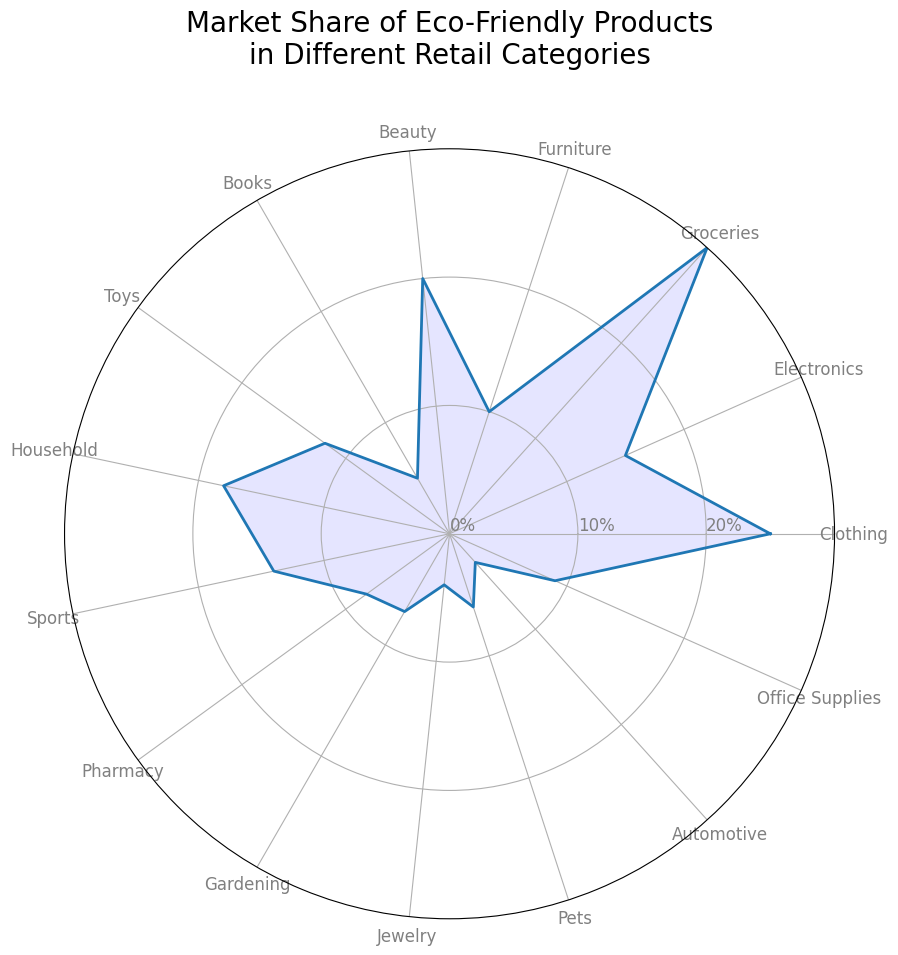Which category has the highest market share of eco-friendly products? Look for the longest segment on the rose chart, which corresponds to the largest percentage. The category with the longest segment is Groceries with 30%.
Answer: Groceries Which category has the lowest market share? Look for the shortest segment on the rose chart, which corresponds to the smallest percentage. The category with the shortest segment is Automotive with 3%.
Answer: Automotive What is the difference in market share between Groceries and Clothing? Groceries have a market share of 30% and Clothing has 25%. The difference is 30% - 25% = 5%.
Answer: 5% How many categories have a market share of 10% or above? Count the segments that reach at least the 10% ring. These categories are Clothing, Electronics, Groceries, Beauty, Household, Sports, and Pharmacy. There are 7 such categories.
Answer: 7 Which category has a market share closest to 10%? Identify the segments that are near the 10% mark. The closest category is Furniture with a market share of exactly 10%.
Answer: Furniture What is the combined market share of Clothing, Electronics, and Groceries? Add up the percentages for Clothing (25%), Electronics (15%), and Groceries (30%). The combined market share is 25% + 15% + 30% = 70%.
Answer: 70% Is the market share of Electronics greater than that of Sports and Jewelry combined? Electronics have a 15% share, Sports have 14%, and Jewelry has 4%. Combined, Sports and Jewelry have 14% + 4% = 18%, which is higher than Electronics' 15%.
Answer: No What is the total market share of categories in the beauty and household sectors? Add the percentages for Beauty (20%) and Household (18%). The total market share is 20% + 18% = 38%.
Answer: 38% Which two categories have the closest market share percentages? Identify the segments that are nearest in length. Sports (14%) and Electronics (15%) are closest, with a difference of 1%.
Answer: Sports and Electronics Which category has a larger market share: Books or Pharmacy? Compare the segments for Books (5%) and Pharmacy (8%). Pharmacy's segment is longer, so it has a larger market share.
Answer: Pharmacy 